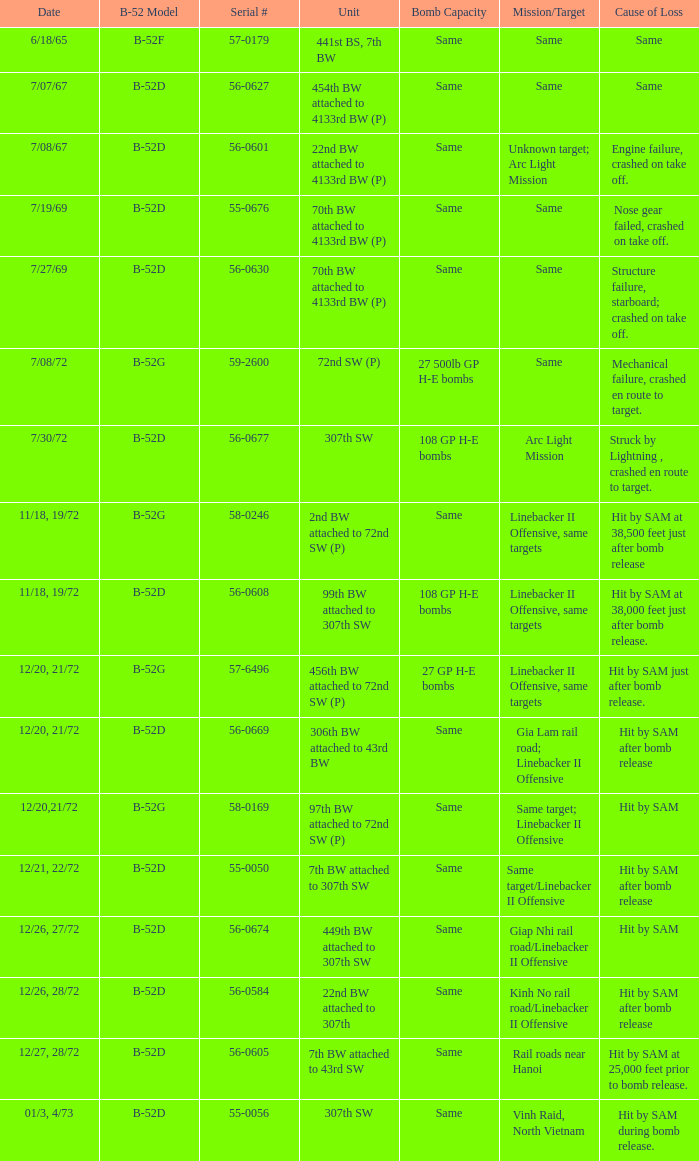When same objective; linebacker ii offense is the same objective, what is the unit? 97th BW attached to 72nd SW (P). 